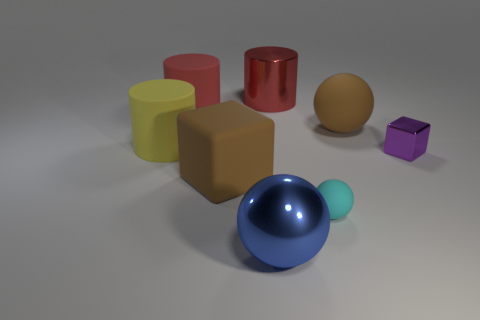What is the color of the block in front of the block right of the matte object that is to the right of the tiny cyan matte thing?
Offer a terse response. Brown. There is a large thing that is on the left side of the big shiny ball and behind the big rubber sphere; what is its shape?
Offer a very short reply. Cylinder. Are there any other things that are the same size as the metallic cube?
Your response must be concise. Yes. The large ball that is on the right side of the big shiny thing behind the yellow rubber object is what color?
Provide a succinct answer. Brown. There is a brown rubber object that is in front of the rubber cylinder left of the big red object that is left of the metallic ball; what is its shape?
Provide a succinct answer. Cube. What size is the thing that is both in front of the large matte sphere and right of the small matte object?
Your response must be concise. Small. How many big metallic things have the same color as the metallic cylinder?
Give a very brief answer. 0. What is the material of the cube that is the same color as the large rubber sphere?
Keep it short and to the point. Rubber. What is the material of the tiny purple cube?
Provide a short and direct response. Metal. Is the material of the red cylinder on the right side of the metallic ball the same as the yellow cylinder?
Make the answer very short. No. 